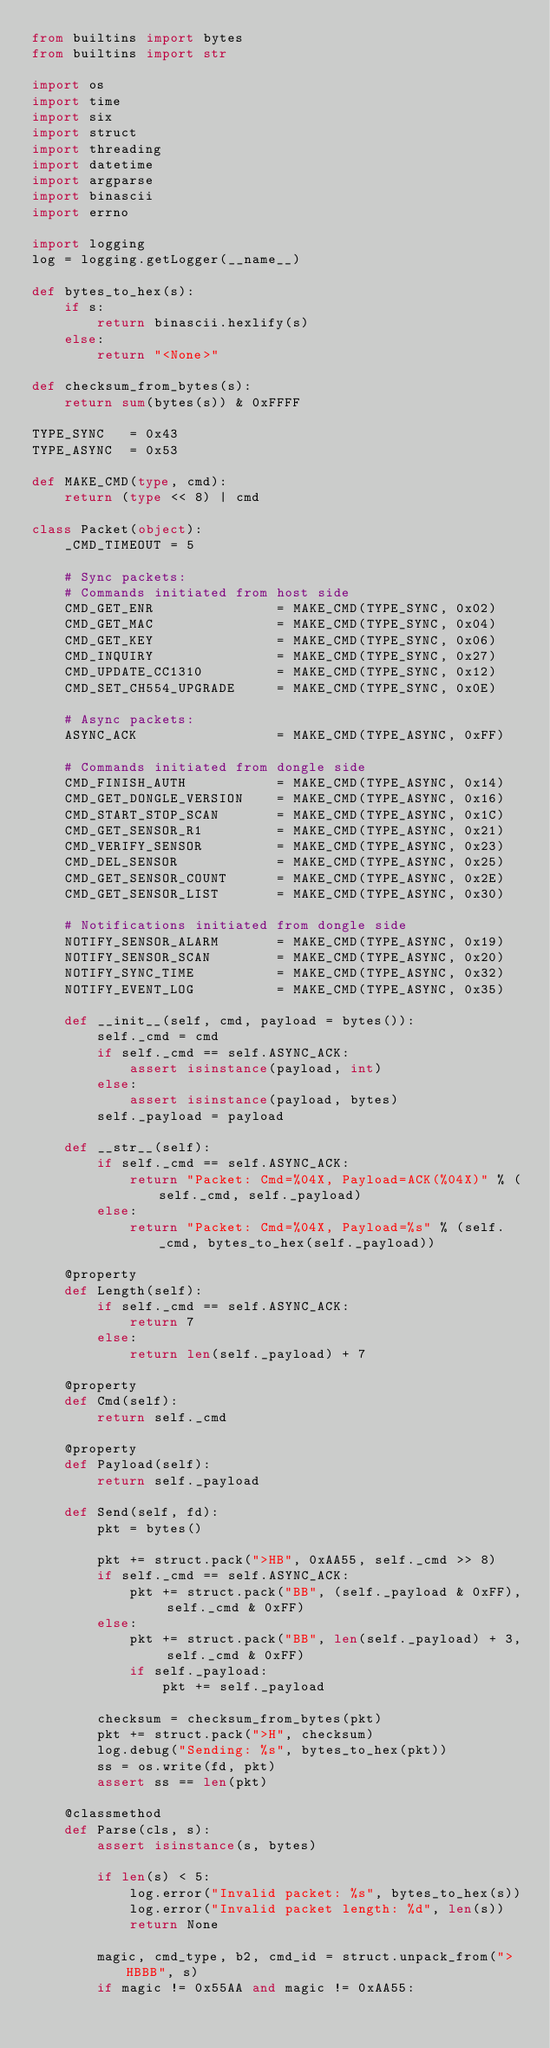<code> <loc_0><loc_0><loc_500><loc_500><_Python_>from builtins import bytes
from builtins import str

import os
import time
import six
import struct
import threading
import datetime
import argparse
import binascii
import errno

import logging
log = logging.getLogger(__name__)

def bytes_to_hex(s):
    if s:
        return binascii.hexlify(s)
    else:
        return "<None>"

def checksum_from_bytes(s):
    return sum(bytes(s)) & 0xFFFF

TYPE_SYNC   = 0x43
TYPE_ASYNC  = 0x53

def MAKE_CMD(type, cmd):
    return (type << 8) | cmd

class Packet(object):
    _CMD_TIMEOUT = 5

    # Sync packets:
    # Commands initiated from host side
    CMD_GET_ENR               = MAKE_CMD(TYPE_SYNC, 0x02)
    CMD_GET_MAC               = MAKE_CMD(TYPE_SYNC, 0x04)
    CMD_GET_KEY               = MAKE_CMD(TYPE_SYNC, 0x06)
    CMD_INQUIRY               = MAKE_CMD(TYPE_SYNC, 0x27)
    CMD_UPDATE_CC1310         = MAKE_CMD(TYPE_SYNC, 0x12)
    CMD_SET_CH554_UPGRADE     = MAKE_CMD(TYPE_SYNC, 0x0E)

    # Async packets:
    ASYNC_ACK                 = MAKE_CMD(TYPE_ASYNC, 0xFF)

    # Commands initiated from dongle side
    CMD_FINISH_AUTH           = MAKE_CMD(TYPE_ASYNC, 0x14)
    CMD_GET_DONGLE_VERSION    = MAKE_CMD(TYPE_ASYNC, 0x16)
    CMD_START_STOP_SCAN       = MAKE_CMD(TYPE_ASYNC, 0x1C)
    CMD_GET_SENSOR_R1         = MAKE_CMD(TYPE_ASYNC, 0x21)
    CMD_VERIFY_SENSOR         = MAKE_CMD(TYPE_ASYNC, 0x23)
    CMD_DEL_SENSOR            = MAKE_CMD(TYPE_ASYNC, 0x25)
    CMD_GET_SENSOR_COUNT      = MAKE_CMD(TYPE_ASYNC, 0x2E)
    CMD_GET_SENSOR_LIST       = MAKE_CMD(TYPE_ASYNC, 0x30)

    # Notifications initiated from dongle side
    NOTIFY_SENSOR_ALARM       = MAKE_CMD(TYPE_ASYNC, 0x19)
    NOTIFY_SENSOR_SCAN        = MAKE_CMD(TYPE_ASYNC, 0x20)
    NOTIFY_SYNC_TIME          = MAKE_CMD(TYPE_ASYNC, 0x32)
    NOTIFY_EVENT_LOG          = MAKE_CMD(TYPE_ASYNC, 0x35)

    def __init__(self, cmd, payload = bytes()):
        self._cmd = cmd
        if self._cmd == self.ASYNC_ACK:
            assert isinstance(payload, int)
        else:
            assert isinstance(payload, bytes)
        self._payload = payload

    def __str__(self):
        if self._cmd == self.ASYNC_ACK:
            return "Packet: Cmd=%04X, Payload=ACK(%04X)" % (self._cmd, self._payload)
        else:
            return "Packet: Cmd=%04X, Payload=%s" % (self._cmd, bytes_to_hex(self._payload))

    @property
    def Length(self):
        if self._cmd == self.ASYNC_ACK:
            return 7
        else:
            return len(self._payload) + 7

    @property
    def Cmd(self):
        return self._cmd
    
    @property
    def Payload(self):
        return self._payload

    def Send(self, fd):
        pkt = bytes()
        
        pkt += struct.pack(">HB", 0xAA55, self._cmd >> 8)
        if self._cmd == self.ASYNC_ACK:
            pkt += struct.pack("BB", (self._payload & 0xFF), self._cmd & 0xFF)
        else:
            pkt += struct.pack("BB", len(self._payload) + 3, self._cmd & 0xFF)
            if self._payload:
                pkt += self._payload

        checksum = checksum_from_bytes(pkt)
        pkt += struct.pack(">H", checksum)
        log.debug("Sending: %s", bytes_to_hex(pkt))
        ss = os.write(fd, pkt)
        assert ss == len(pkt)

    @classmethod
    def Parse(cls, s):
        assert isinstance(s, bytes)

        if len(s) < 5:
            log.error("Invalid packet: %s", bytes_to_hex(s))
            log.error("Invalid packet length: %d", len(s))
            return None

        magic, cmd_type, b2, cmd_id = struct.unpack_from(">HBBB", s)
        if magic != 0x55AA and magic != 0xAA55:</code> 